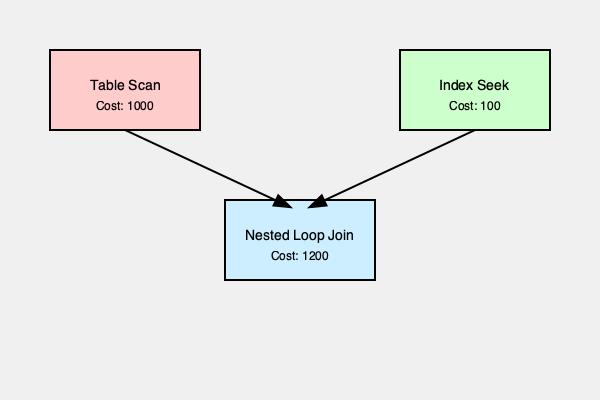In the given execution plan diagram for a database query, which operation is the most costly and what can be done to potentially optimize the query performance? To analyze the execution plan and optimize the query performance, let's follow these steps:

1. Identify the operations:
   - Table Scan (Cost: 1000)
   - Index Seek (Cost: 100)
   - Nested Loop Join (Cost: 1200)

2. Compare the costs:
   - The Nested Loop Join has the highest cost at 1200
   - The Table Scan is the second most expensive at 1000
   - The Index Seek is the least expensive at 100

3. Analyze the bottleneck:
   - The Table Scan is significantly more expensive than the Index Seek
   - The high cost of the Table Scan contributes to the overall high cost of the Nested Loop Join

4. Identify optimization opportunity:
   - Replace the Table Scan with an Index Seek or Index Scan
   - This can be done by creating an appropriate index on the table being scanned

5. Potential benefits:
   - Reducing the cost of the Table Scan operation
   - Consequently reducing the cost of the Nested Loop Join
   - Overall improvement in query performance

6. Implementation:
   - Analyze the WHERE clause and JOIN conditions of the query
   - Identify the columns used in these conditions
   - Create an index on these columns to enable an Index Seek or Index Scan

By focusing on replacing the Table Scan with a more efficient index-based operation, we can potentially significantly reduce the overall cost of the query execution plan.
Answer: Replace Table Scan with Index Seek by creating appropriate index. 